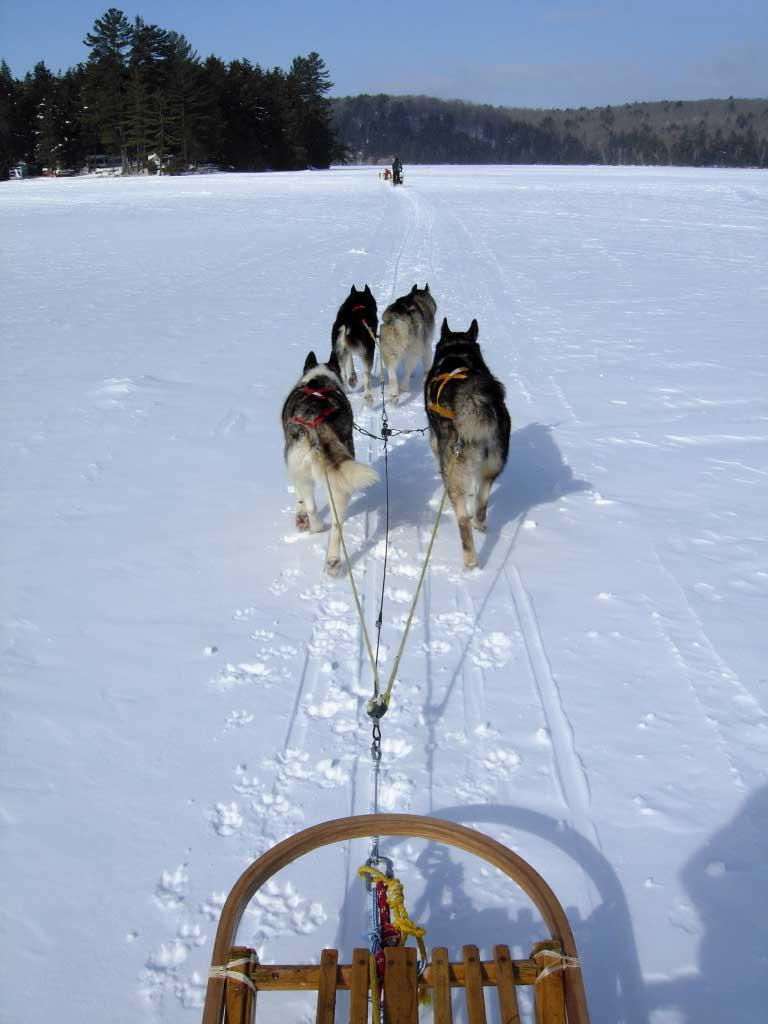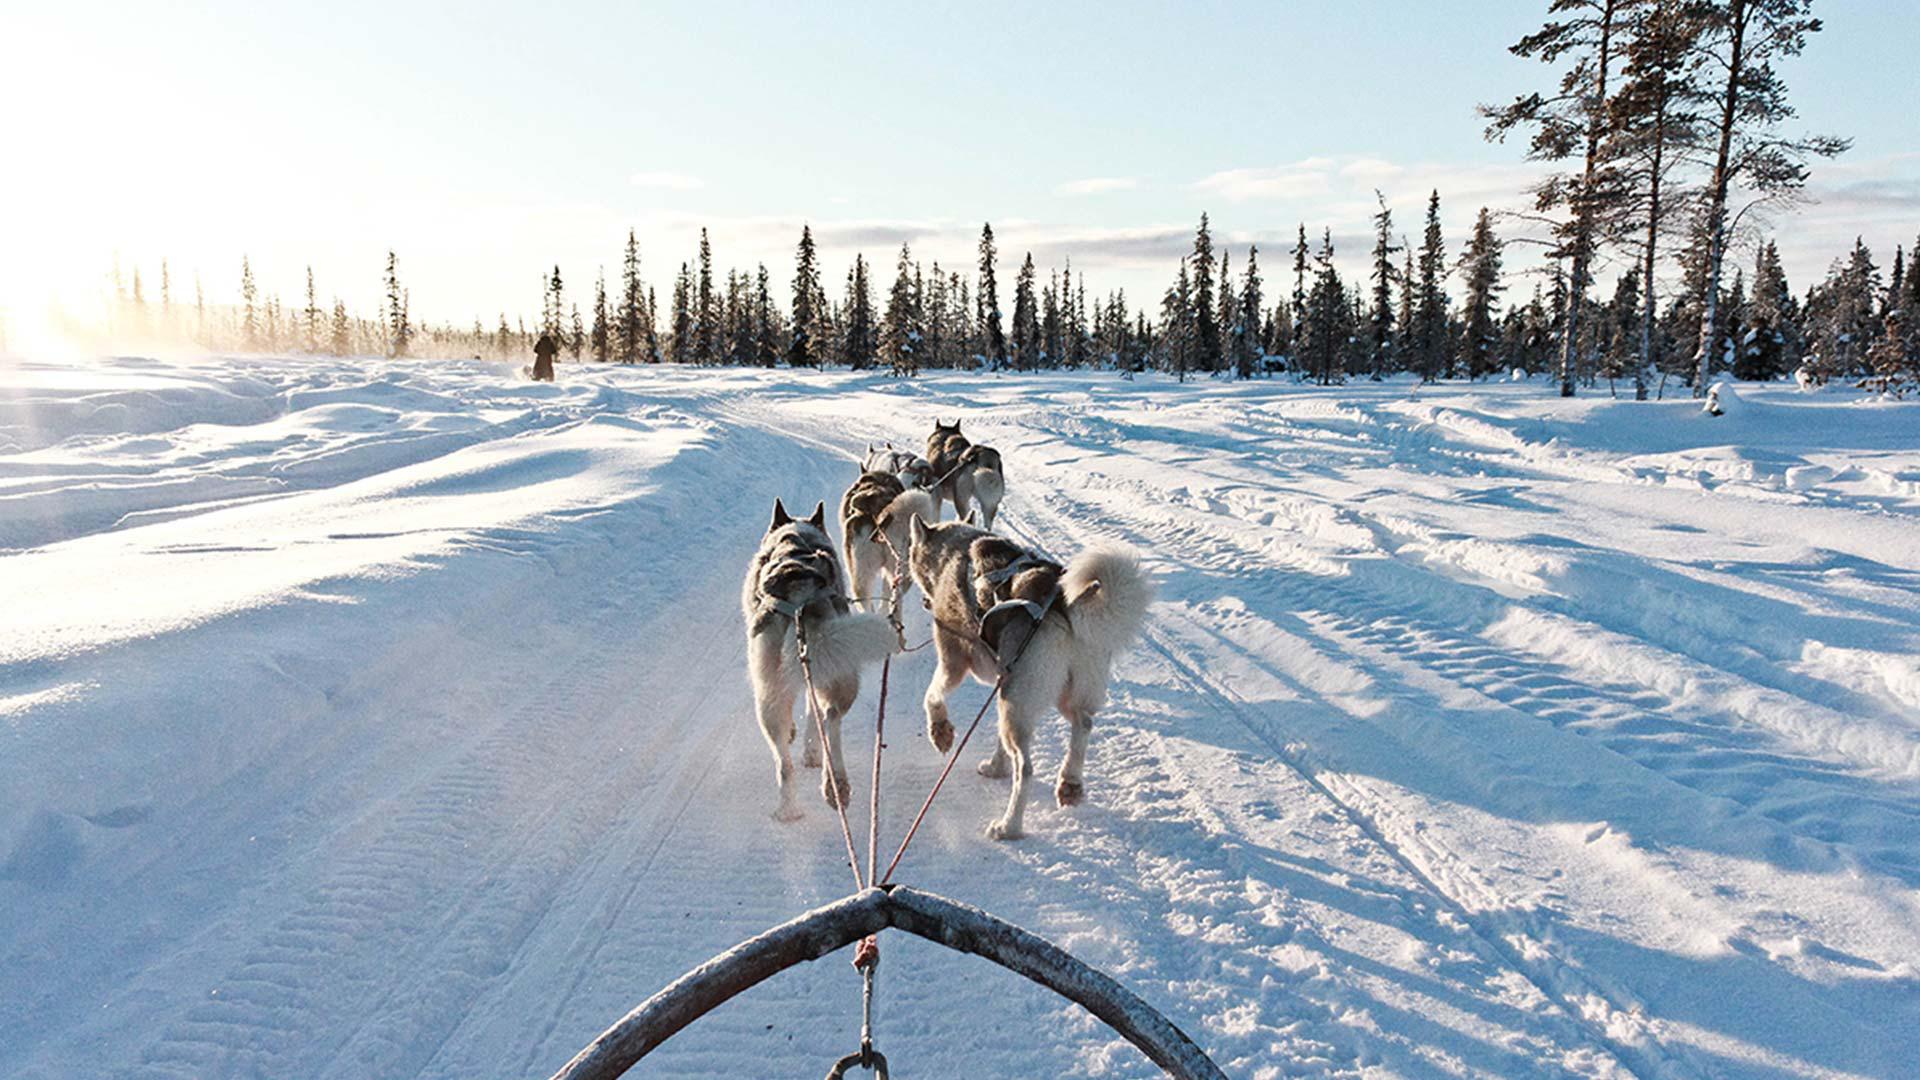The first image is the image on the left, the second image is the image on the right. For the images shown, is this caption "There are trees lining the trail in the image on the right" true? Answer yes or no. No. The first image is the image on the left, the second image is the image on the right. For the images displayed, is the sentence "An image shows a semi-circle wooden front of a sled at the bottom." factually correct? Answer yes or no. Yes. 